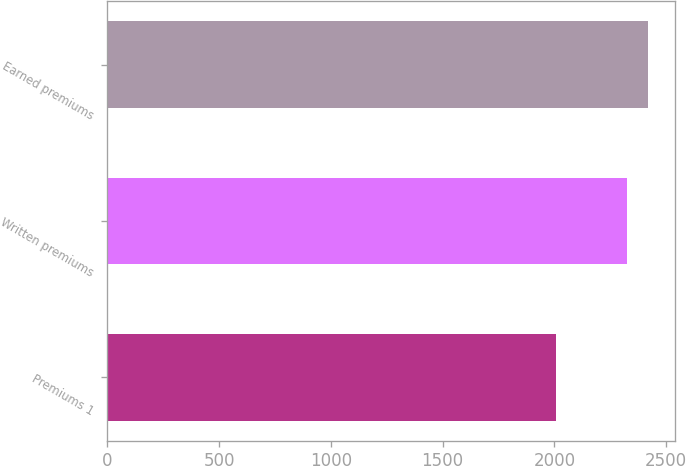Convert chart. <chart><loc_0><loc_0><loc_500><loc_500><bar_chart><fcel>Premiums 1<fcel>Written premiums<fcel>Earned premiums<nl><fcel>2007<fcel>2326<fcel>2420<nl></chart> 